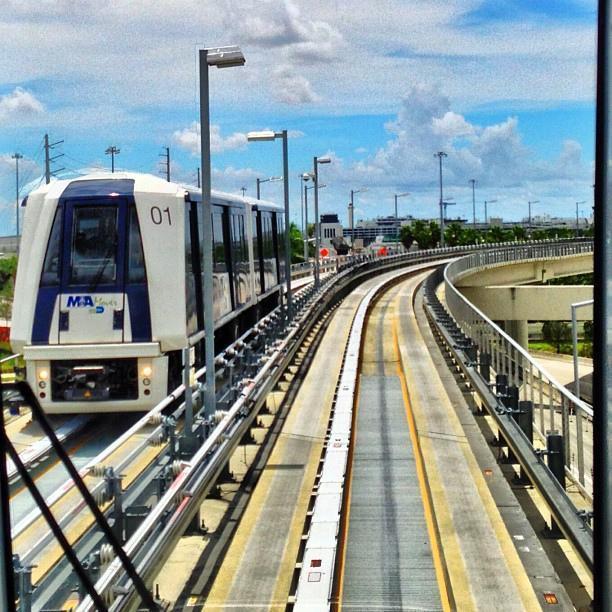How many train tracks are there?
Give a very brief answer. 2. 